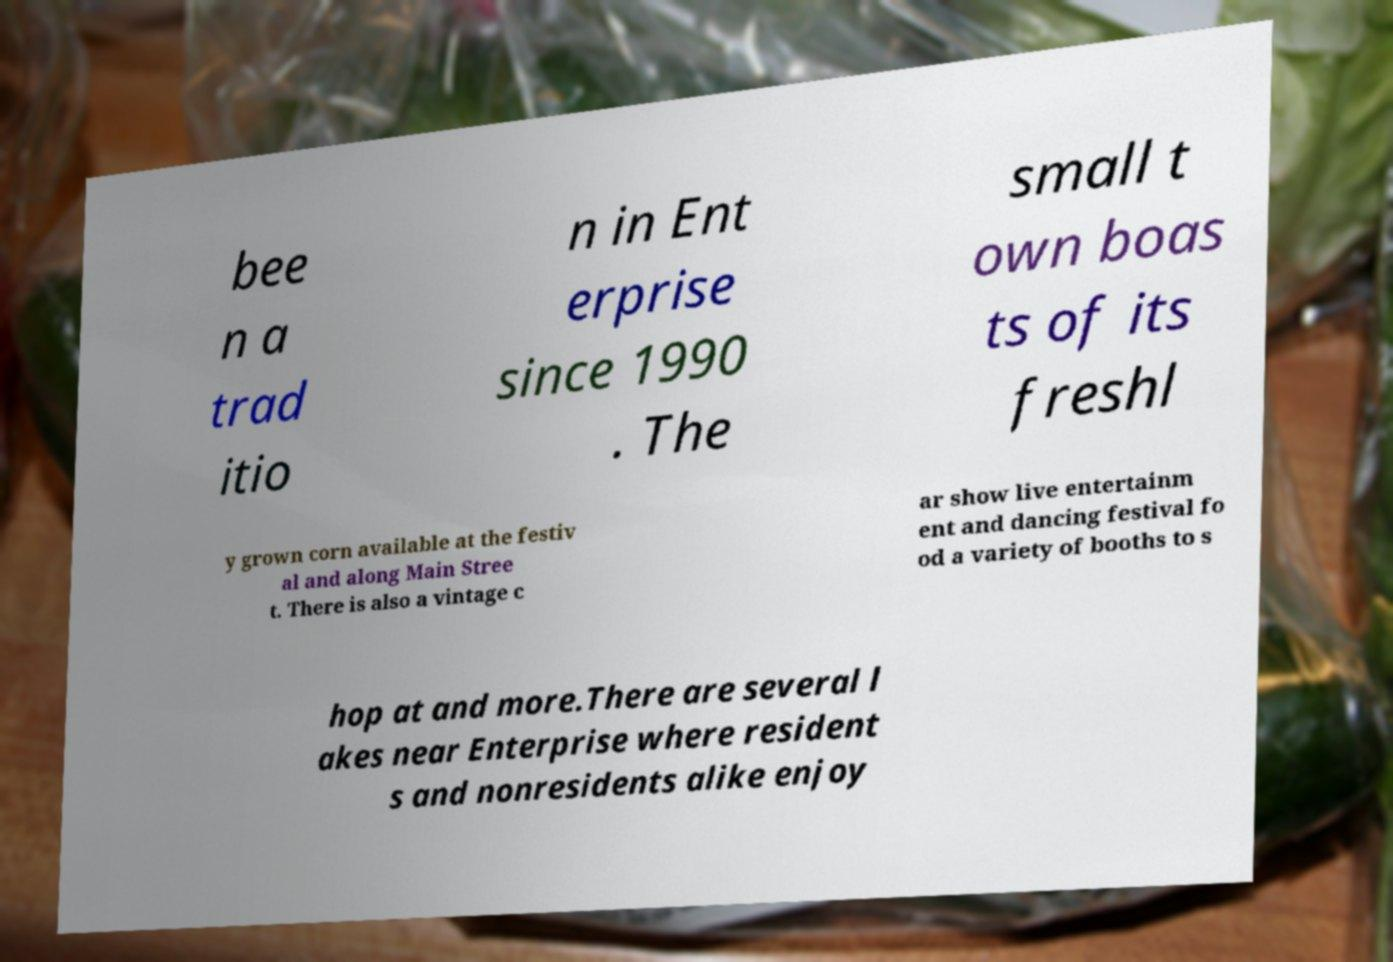Can you read and provide the text displayed in the image?This photo seems to have some interesting text. Can you extract and type it out for me? bee n a trad itio n in Ent erprise since 1990 . The small t own boas ts of its freshl y grown corn available at the festiv al and along Main Stree t. There is also a vintage c ar show live entertainm ent and dancing festival fo od a variety of booths to s hop at and more.There are several l akes near Enterprise where resident s and nonresidents alike enjoy 